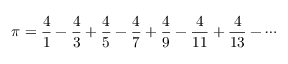Convert formula to latex. <formula><loc_0><loc_0><loc_500><loc_500>\pi = { \frac { 4 } { 1 } } - { \frac { 4 } { 3 } } + { \frac { 4 } { 5 } } - { \frac { 4 } { 7 } } + { \frac { 4 } { 9 } } - { \frac { 4 } { 1 1 } } + { \frac { 4 } { 1 3 } } - \cdots</formula> 